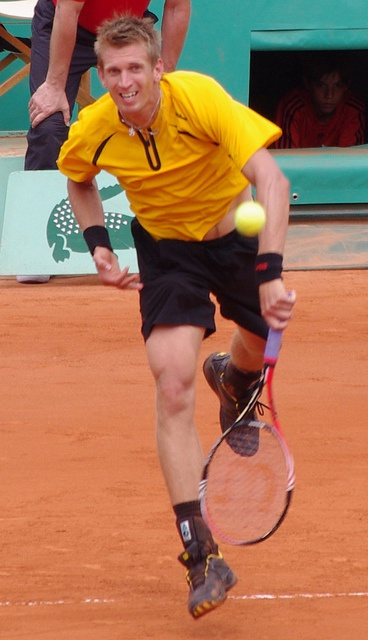Describe the objects in this image and their specific colors. I can see people in teal, black, brown, orange, and red tones, tennis racket in teal, salmon, maroon, and brown tones, people in teal, black, brown, maroon, and purple tones, people in teal, black, maroon, and gray tones, and sports ball in teal, lightyellow, khaki, and tan tones in this image. 